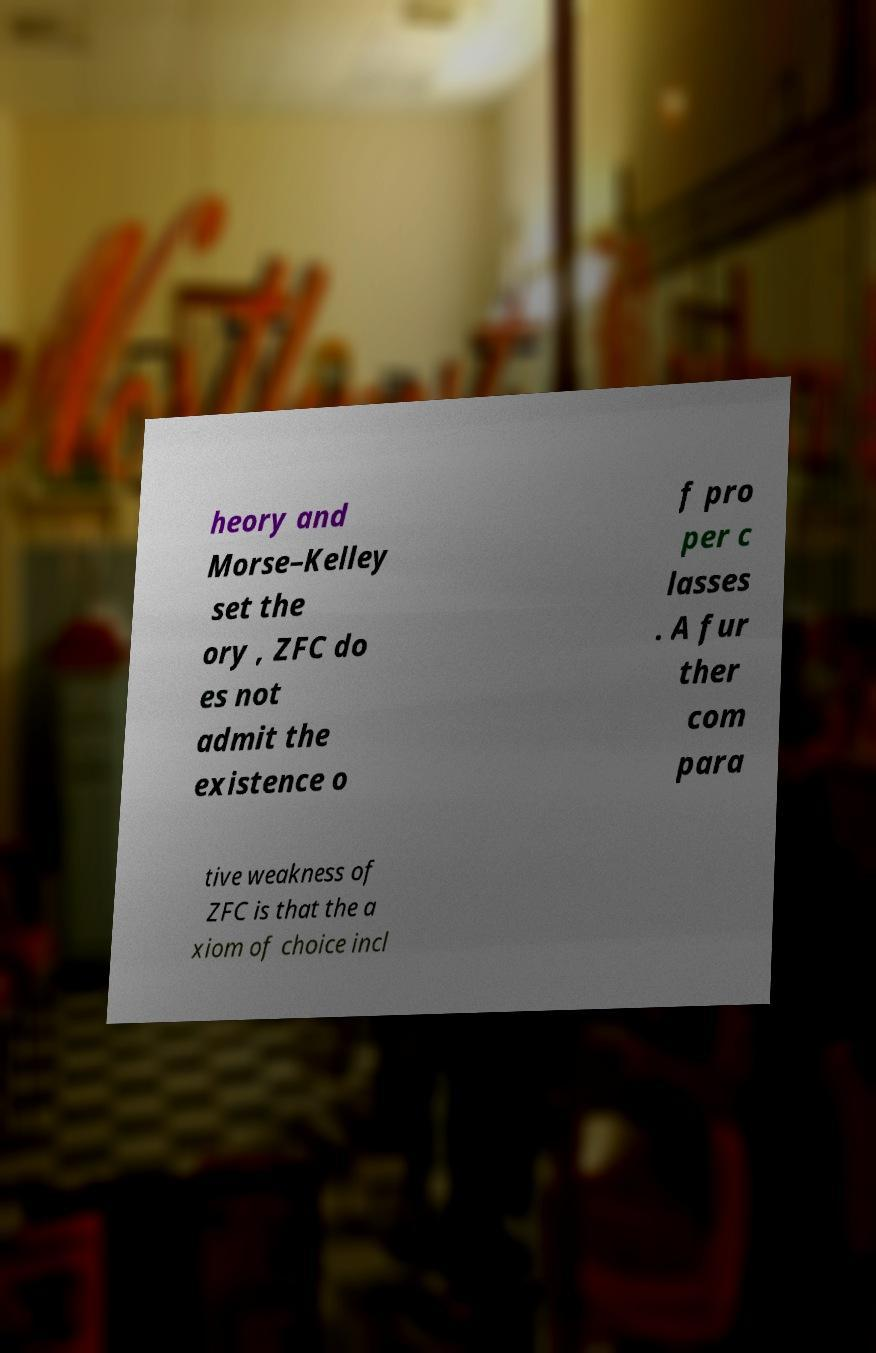Can you accurately transcribe the text from the provided image for me? heory and Morse–Kelley set the ory , ZFC do es not admit the existence o f pro per c lasses . A fur ther com para tive weakness of ZFC is that the a xiom of choice incl 